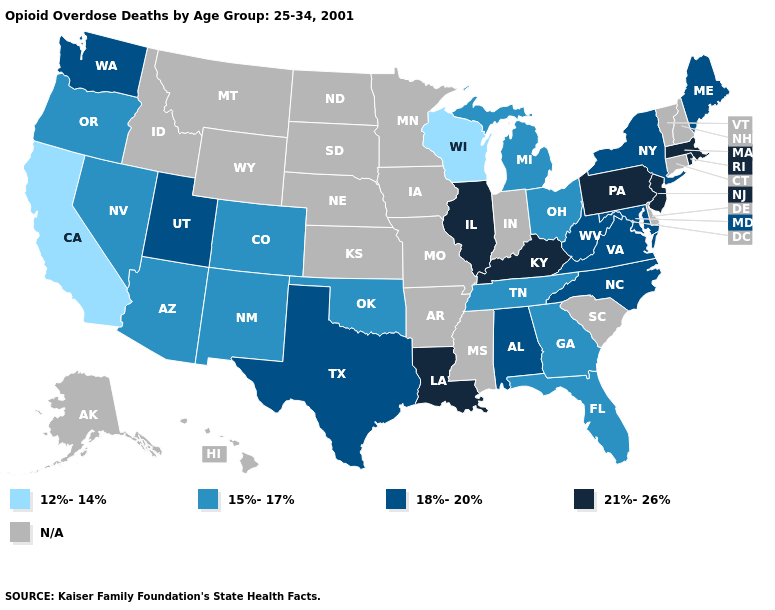What is the value of Utah?
Write a very short answer. 18%-20%. Which states have the lowest value in the USA?
Keep it brief. California, Wisconsin. Among the states that border Ohio , does West Virginia have the lowest value?
Concise answer only. No. What is the value of Montana?
Quick response, please. N/A. Among the states that border New Jersey , which have the lowest value?
Short answer required. New York. Name the states that have a value in the range 21%-26%?
Keep it brief. Illinois, Kentucky, Louisiana, Massachusetts, New Jersey, Pennsylvania, Rhode Island. Which states hav the highest value in the West?
Give a very brief answer. Utah, Washington. Name the states that have a value in the range 12%-14%?
Short answer required. California, Wisconsin. Which states have the lowest value in the Northeast?
Write a very short answer. Maine, New York. Among the states that border Wisconsin , does Illinois have the highest value?
Keep it brief. Yes. Does the first symbol in the legend represent the smallest category?
Short answer required. Yes. Does Nevada have the lowest value in the USA?
Give a very brief answer. No. Among the states that border Connecticut , does New York have the lowest value?
Give a very brief answer. Yes. 